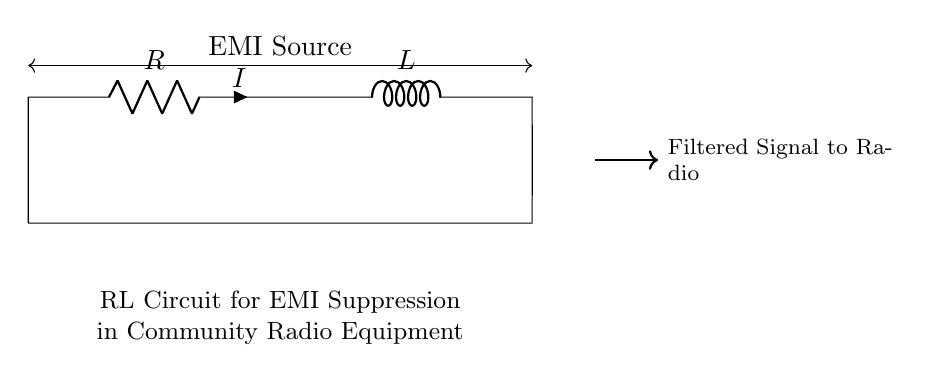What components are present in this circuit? The circuit diagram shows a resistor (R) and an inductor (L), which are connected in series. These components are labeled clearly in the diagram.
Answer: Resistor and Inductor What is the direction of current flow in the circuit? The current (I) flows from the bottom to the top of the resistor, then continues into the inductor, confirming a single direction according to conventional current flow in a series circuit.
Answer: Upward What does the arrow represent in the circuit? The arrow indicates the direction of the filtered signal moving from the circuit to the radio, suggesting the output path of the circuitry after suppression of electromagnetic interference.
Answer: Filtered Signal Direction What is the relationship between the resistor and the inductor in this circuit? Together, the resistor and inductor form an RL circuit which primarily serves to suppress electromagnetic interference by filtering out unwanted signals. This interplay helps smooth out the input to the radio.
Answer: EMI Suppression How does this RL circuit help with electromagnetic interference suppression? The resistor limits the current while the inductor generates a magnetic field opposing changes in current, effectively filtering out rapid fluctuations that cause EMI, thus providing a cleaner signal to the radio.
Answer: It filters out rapid current changes What is typically the purpose of an RL circuit in community radio equipment? The primary role of the RL circuit in community radio equipment is to minimize unwanted electromagnetic signals, allowing for clearer audio reception and improved overall performance of the radio transmission system.
Answer: Signal Clarity 